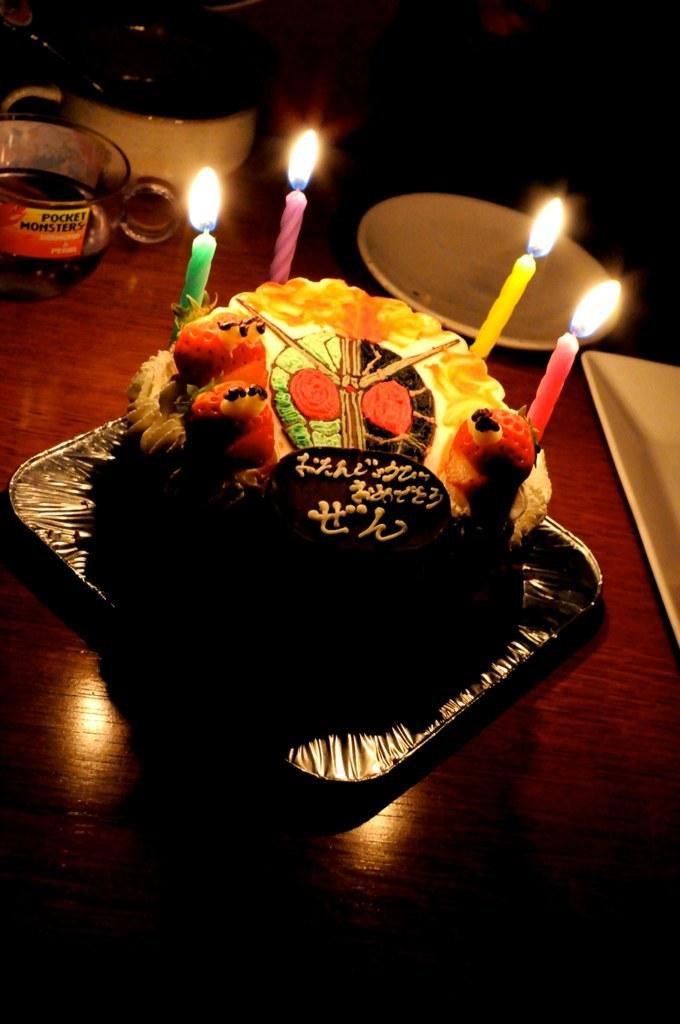What type of furniture is present in the image? There is a table in the image. What is placed on the table in the image? There is a cake on a serving plate with candles in the image. What type of beverage container is visible in the image? Coffee cups are visible in the image. What accompanies the coffee cups in the image? There are saucers in the image. What is used to serve the cake in the image? There is a serving plate in the image. What type of oranges are being used to answer questions in the image? There are no oranges or questions being answered in the image; it features a table with a cake, coffee cups, saucers, and a serving plate. 